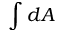<formula> <loc_0><loc_0><loc_500><loc_500>\int d A</formula> 